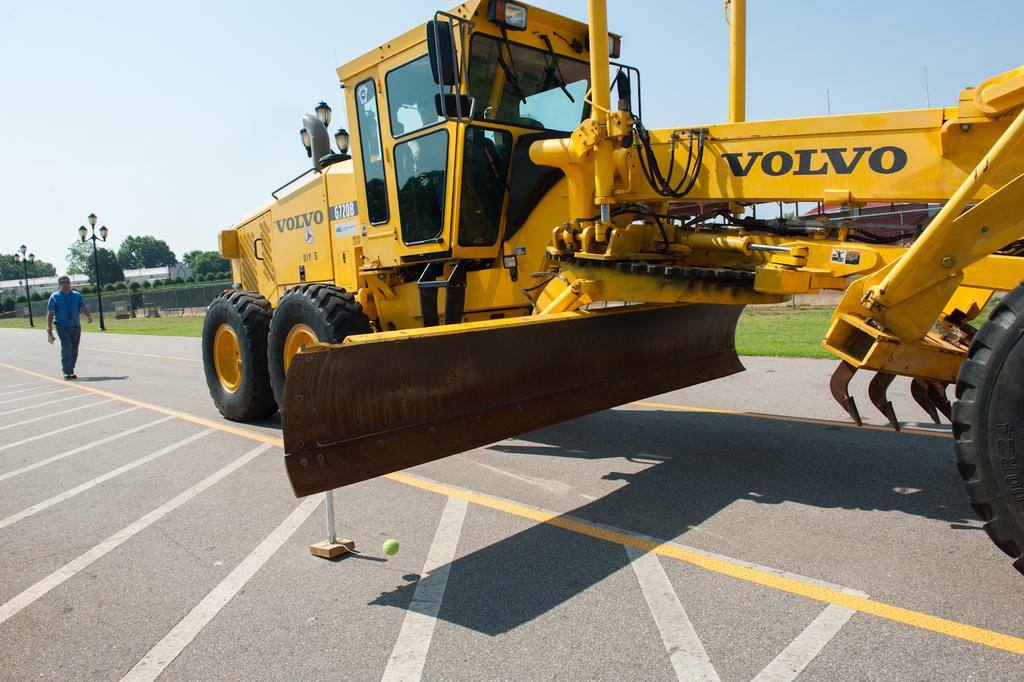What company is this large construction equipment from?
Offer a very short reply. Volvo. Who built the equipment?
Ensure brevity in your answer.  Volvo. 